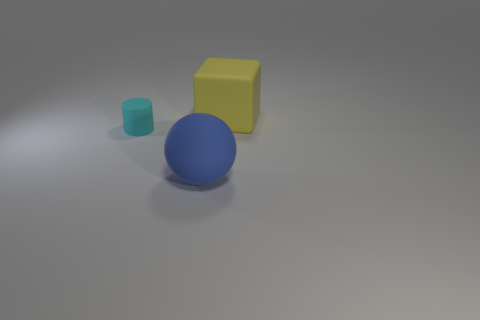Add 1 tiny cyan objects. How many objects exist? 4 Subtract all balls. How many objects are left? 2 Add 3 blue spheres. How many blue spheres exist? 4 Subtract 0 blue blocks. How many objects are left? 3 Subtract all blue cubes. Subtract all cyan objects. How many objects are left? 2 Add 2 big rubber spheres. How many big rubber spheres are left? 3 